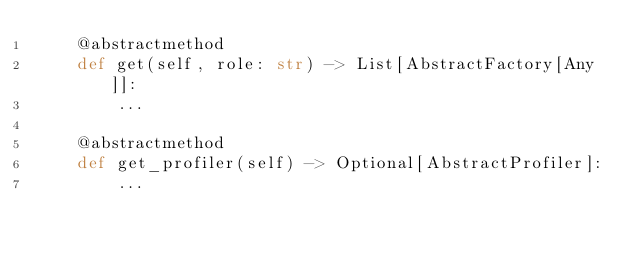<code> <loc_0><loc_0><loc_500><loc_500><_Python_>    @abstractmethod
    def get(self, role: str) -> List[AbstractFactory[Any]]:
        ...

    @abstractmethod
    def get_profiler(self) -> Optional[AbstractProfiler]:
        ...
</code> 